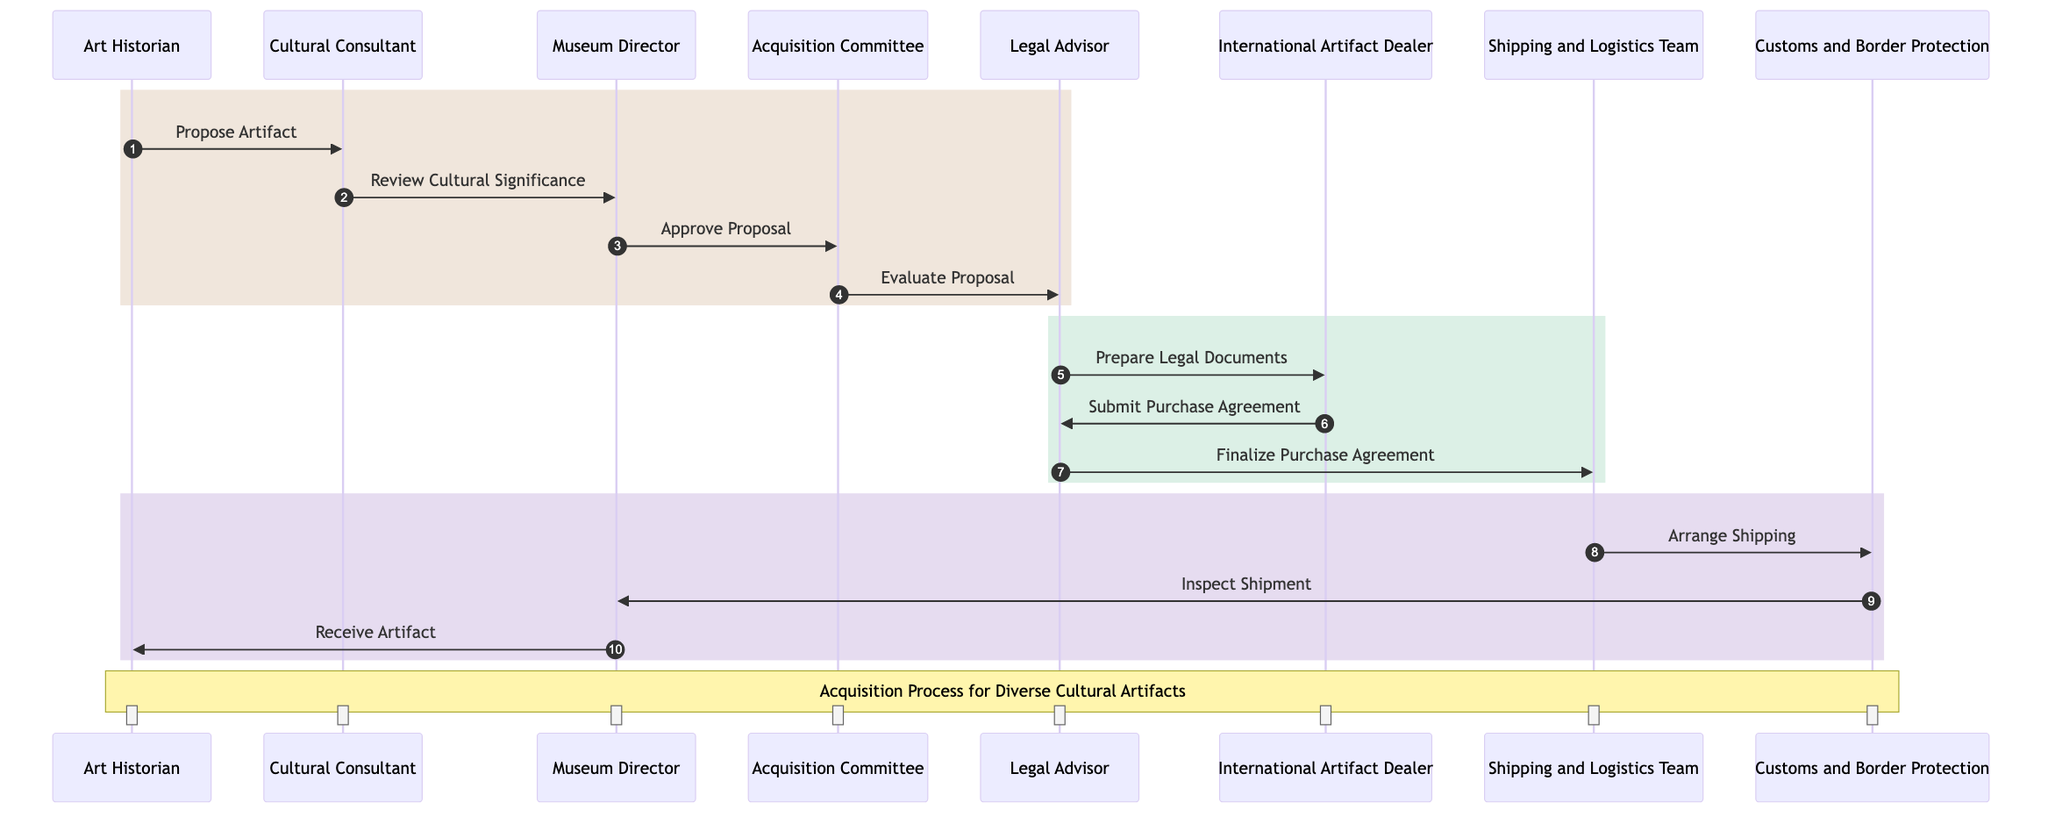What is the first action taken in the acquisition process? The first action in the acquisition process is performed by the Art Historian, who proposes the artifact, as indicated by the arrow connecting 'Art Historian' to 'Cultural Consultant' labeled "Propose Artifact."
Answer: Propose Artifact Which actor reviews the cultural significance of the artifact? The cultural significance of the artifact is reviewed by the Cultural Consultant, as depicted by the arrow from 'Cultural Consultant' to 'Museum Director' with the label "Review Cultural Significance."
Answer: Cultural Consultant How many main steps are there in the acquisition process? The acquisition process consists of three main steps, each represented by a distinct rectangular section in the diagram, delineating actions taken by different actors.
Answer: Three What does the Legal Advisor prepare during the process? The Legal Advisor prepares legal documents, which is shown by the action connecting 'Legal Advisor' to 'International Artifact Dealer' labeled "Prepare Legal Documents."
Answer: Legal Documentation Which team is responsible for arranging shipping? The Shipping and Logistics Team is responsible for arranging shipping, as indicated by the action from 'Shipping and Logistics Team' to 'Customs and Border Protection' labeled "Arrange Shipping."
Answer: Shipping and Logistics Team Who finalizes the purchase agreement? The Legal Advisor finalizes the purchase agreement, as demonstrated by the action connecting 'Legal Advisor' to 'International Artifact Dealer' labeled "Finalize Purchase Agreement."
Answer: Legal Advisor What happens after the Customs and Border Protection inspects the shipment? After Customs and Border Protection inspects the shipment, the Museum Director receives the artifact, shown by the arrow from 'Museum Director' to 'Art Historian' labeled "Receive Artifact."
Answer: Receive Artifact Which two actors are involved in the preparation of legal documentation? The two actors involved in the preparation of legal documentation are the Legal Advisor and the International Artifact Dealer, where the Legal Advisor prepares the documents and the International Artifact Dealer submits the purchase agreement.
Answer: Legal Advisor and International Artifact Dealer Which step follows the evaluation of the proposal by the Acquisition Committee? The step following the evaluation of the proposal by the Acquisition Committee is the preparation of legal documentation by the Legal Advisor, indicated by the flow of actions linking 'Acquisition Committee' to 'Legal Advisor.'
Answer: Prepare Legal Documents 